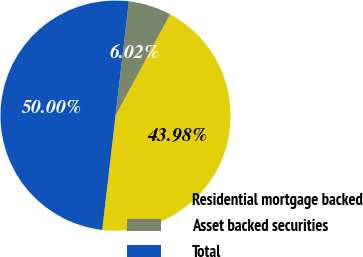Convert chart. <chart><loc_0><loc_0><loc_500><loc_500><pie_chart><fcel>Residential mortgage backed<fcel>Asset backed securities<fcel>Total<nl><fcel>43.98%<fcel>6.02%<fcel>50.0%<nl></chart> 